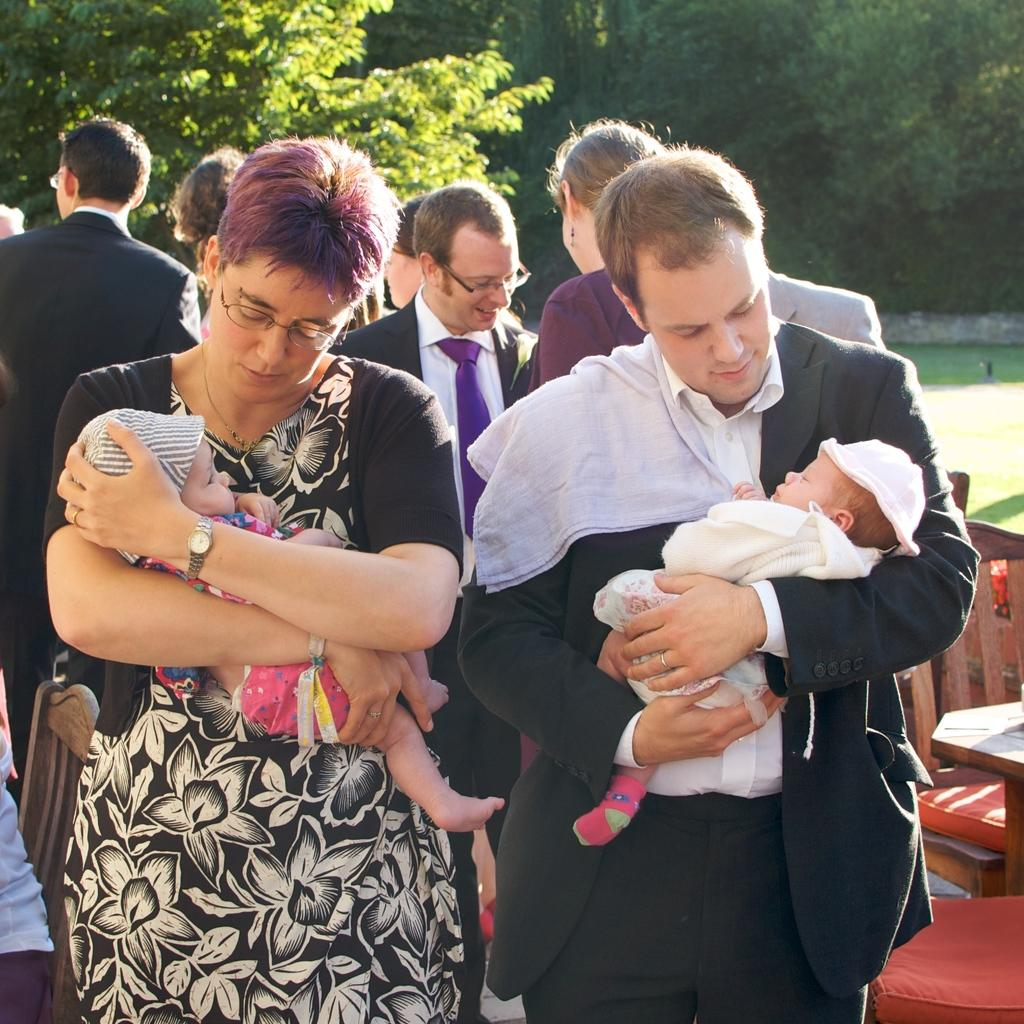What is the general scene depicted in the image? There are people standing in the image. Can you describe the individuals present in the image? There is a man and a woman in the image. What are the woman and the man doing in the image? The woman is carrying a baby in her hands, and the man is also carrying a baby in his hands. What can be seen in the background of the image? There are trees visible in the image. What type of drug is the monkey using in the image? There is no monkey present in the image, and therefore no such activity can be observed. 